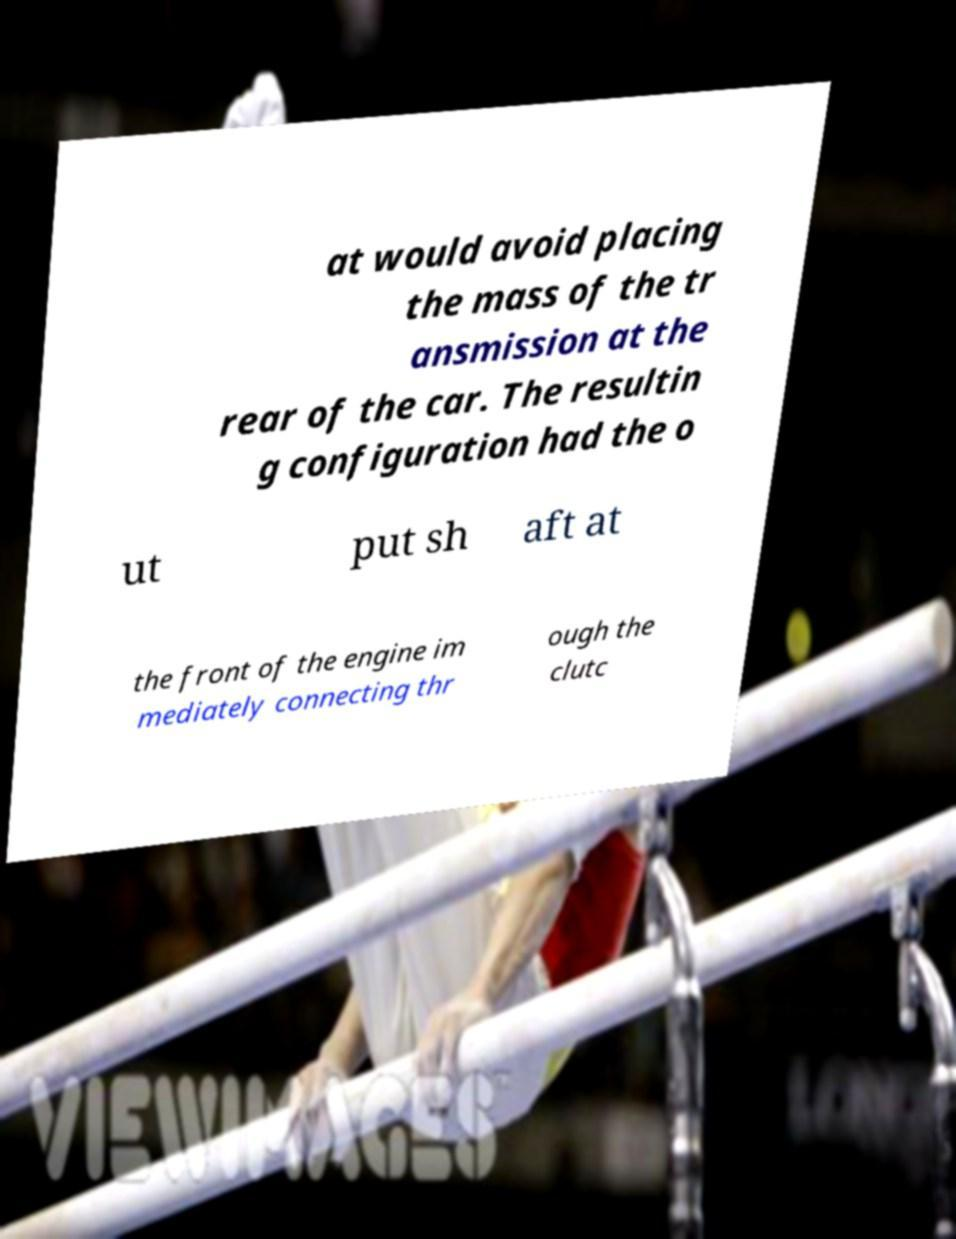I need the written content from this picture converted into text. Can you do that? at would avoid placing the mass of the tr ansmission at the rear of the car. The resultin g configuration had the o ut put sh aft at the front of the engine im mediately connecting thr ough the clutc 